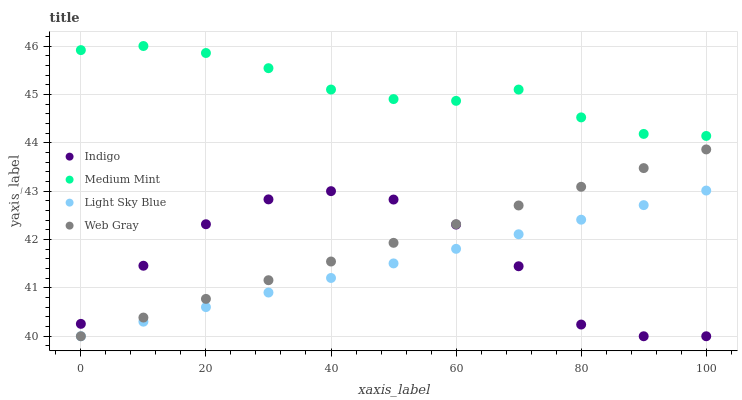Does Light Sky Blue have the minimum area under the curve?
Answer yes or no. Yes. Does Medium Mint have the maximum area under the curve?
Answer yes or no. Yes. Does Indigo have the minimum area under the curve?
Answer yes or no. No. Does Indigo have the maximum area under the curve?
Answer yes or no. No. Is Light Sky Blue the smoothest?
Answer yes or no. Yes. Is Indigo the roughest?
Answer yes or no. Yes. Is Indigo the smoothest?
Answer yes or no. No. Is Light Sky Blue the roughest?
Answer yes or no. No. Does Light Sky Blue have the lowest value?
Answer yes or no. Yes. Does Medium Mint have the highest value?
Answer yes or no. Yes. Does Light Sky Blue have the highest value?
Answer yes or no. No. Is Web Gray less than Medium Mint?
Answer yes or no. Yes. Is Medium Mint greater than Light Sky Blue?
Answer yes or no. Yes. Does Indigo intersect Light Sky Blue?
Answer yes or no. Yes. Is Indigo less than Light Sky Blue?
Answer yes or no. No. Is Indigo greater than Light Sky Blue?
Answer yes or no. No. Does Web Gray intersect Medium Mint?
Answer yes or no. No. 